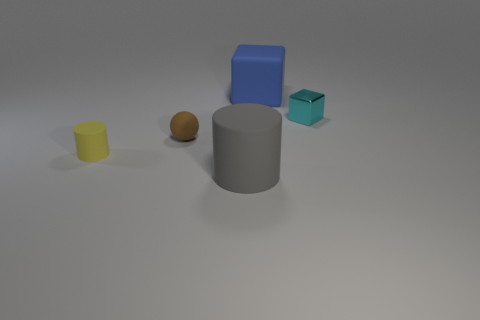Add 3 small matte cylinders. How many objects exist? 8 Subtract all balls. How many objects are left? 4 Add 3 cubes. How many cubes exist? 5 Subtract 1 gray cylinders. How many objects are left? 4 Subtract all small cylinders. Subtract all large cylinders. How many objects are left? 3 Add 4 small cubes. How many small cubes are left? 5 